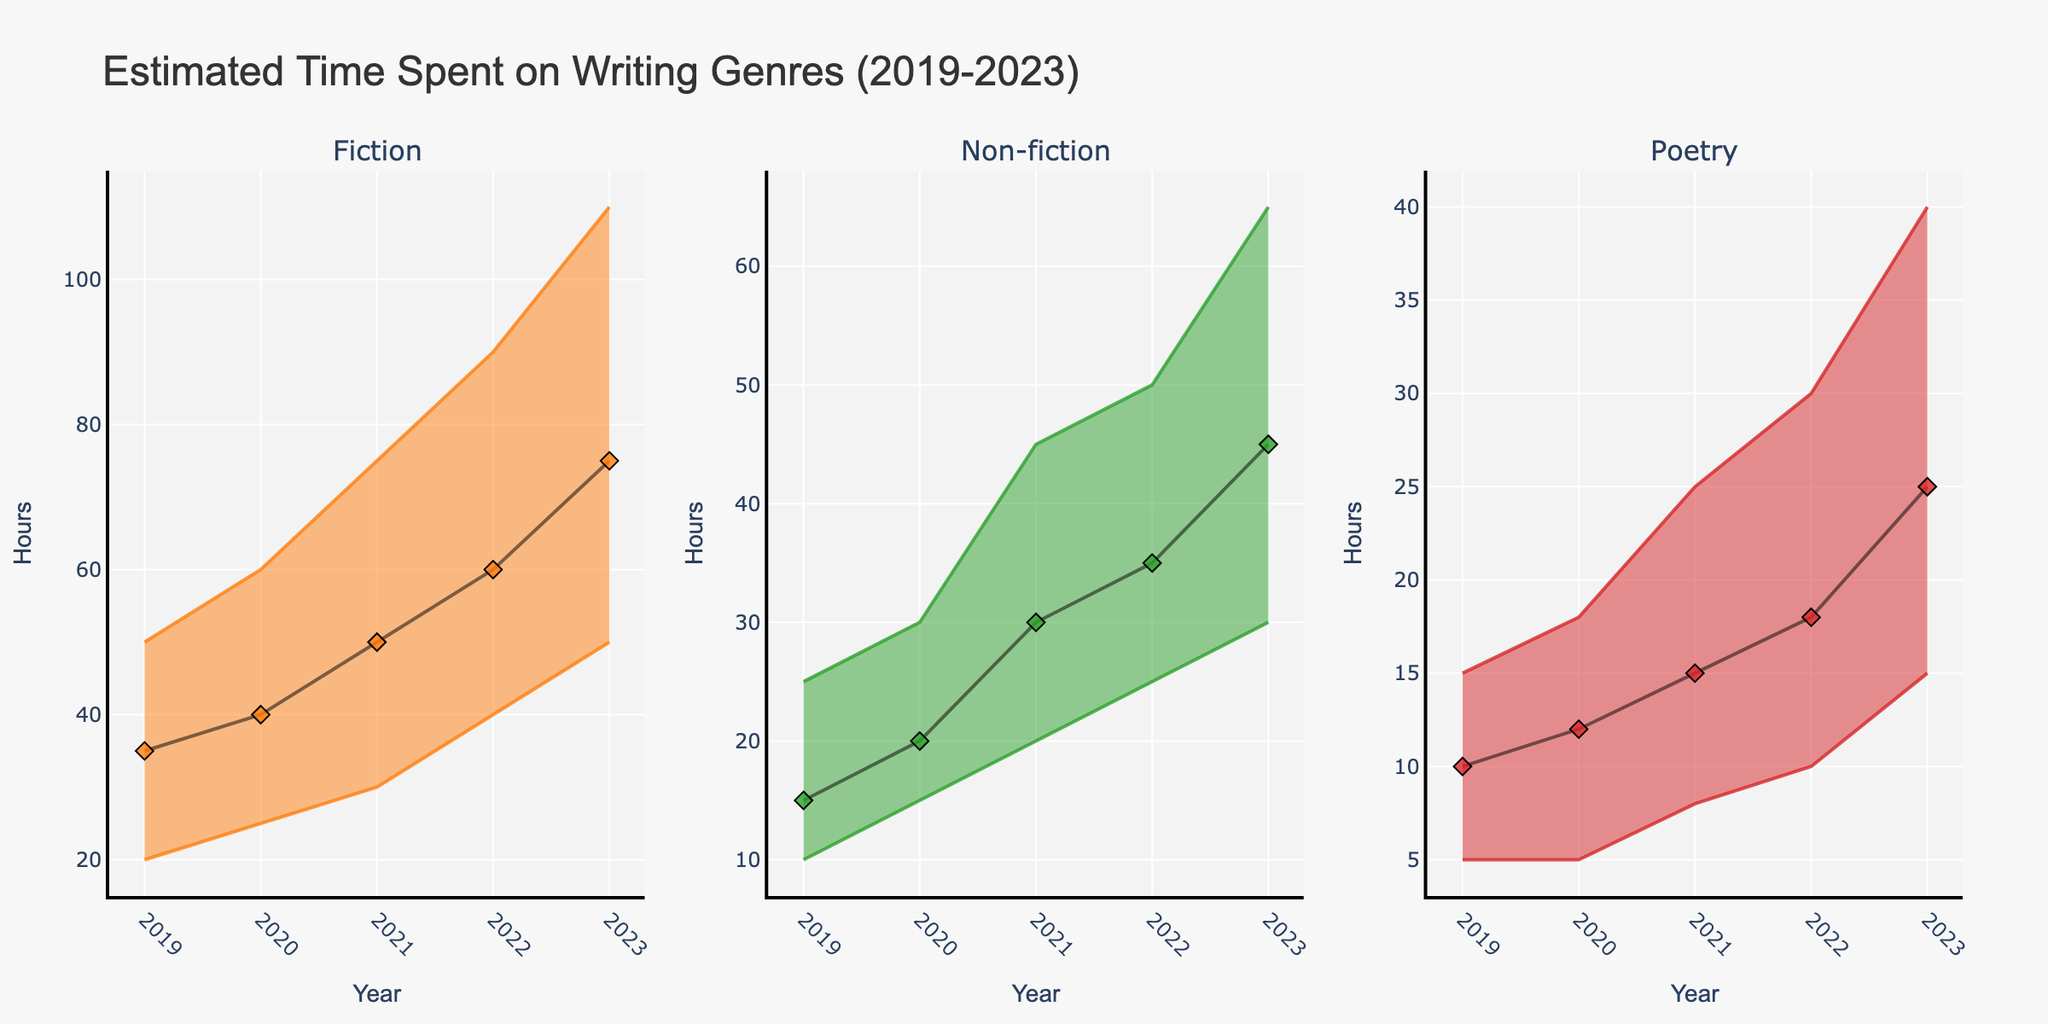What is the title of the figure? The title is displayed at the top of the figure. It reads "Estimated Time Spent on Writing Genres (2019-2023)" which indicates the focus and time period of the data presented.
Answer: Estimated Time Spent on Writing Genres (2019-2023) What are the three genres shown in the figure? The genres are indicated by the subplot titles at the top of each section of the figure. They are "Fiction," "Non-fiction," and "Poetry."
Answer: Fiction, Non-fiction, Poetry Which genre has the highest "High" estimate in 2023? Looking at the year 2023 in each subplot, the "High" estimate is the highest point in each genre. For Fiction, it is 110, for Non-fiction, it is 65, and for Poetry, it is 40. Fiction has the highest value of 110.
Answer: Fiction How much did the "Likely" estimate for Poetry increase from 2019 to 2023? In the Poetry subplot, the "Likely" estimate for 2019 is 10, and for 2023 it is 25. To find the increase, we subtract the 2019 value from the 2023 value: 25 - 10 = 15.
Answer: 15 Which genre showed the largest range between "Low" and "High" estimates in 2021? The range between "Low" and "High" estimates can be found by subtracting the "Low" value from the "High" value for each genre in 2021. For Fiction, it is 75 - 30 = 45. For Non-fiction, it is 45 - 20 = 25. For Poetry, it is 25 - 8 = 17. Fiction has the largest range of 45.
Answer: Fiction In which year did Non-fiction see the highest increase in the "Likely" estimate compared to the previous year? Observing the Non-fiction subplot, we compare the "Likely" estimates year by year: 15 (2019), 20 (2020), 30 (2021), 35 (2022), and 45 (2023). The largest increase is from 2020 to 2021, where it increased by 10 (30 - 20).
Answer: 2021 What is the overall trend for Fiction's "Likely" estimate from 2019 to 2023? In the Fiction subplot, the "Likely" estimates are: 35 (2019), 40 (2020), 50 (2021), 60 (2022), and 75 (2023). The overall trend shows a steady increase every year.
Answer: Steady increase Which genre had the smallest increase in its "Low" estimate between 2019 and 2023? Looking at the "Low" estimates in 2019 and 2023 for each genre: Fiction increased from 20 to 50 (30), Non-fiction from 10 to 30 (20), and Poetry from 5 to 15 (10). Poetry had the smallest increase with 10.
Answer: Poetry By how much did the "High" estimate for Fiction increase from 2022 to 2023? For Fiction, the "High" estimate in 2022 is 90 and in 2023 is 110. To find the increase: 110 - 90 = 20.
Answer: 20 